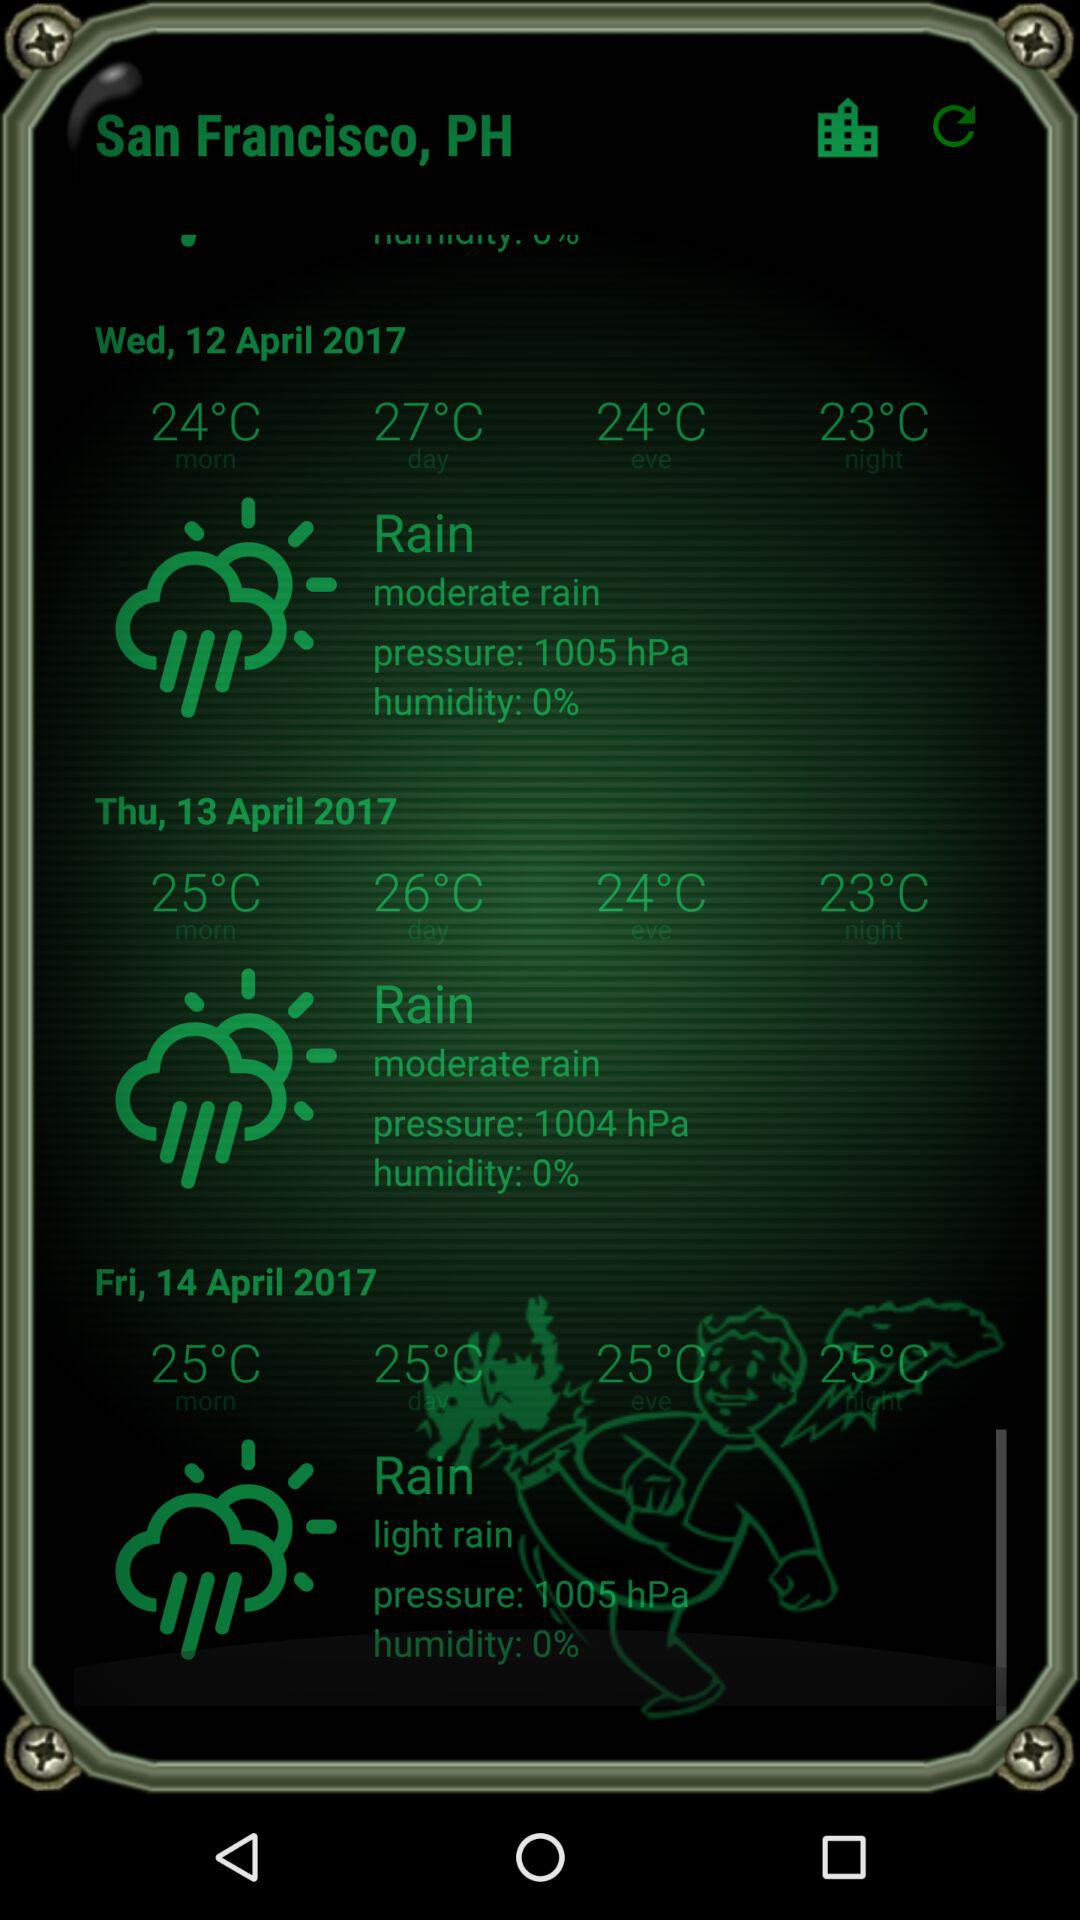What is the humidity level for Wednesday? The humidity level for Wednesday is 0%. 